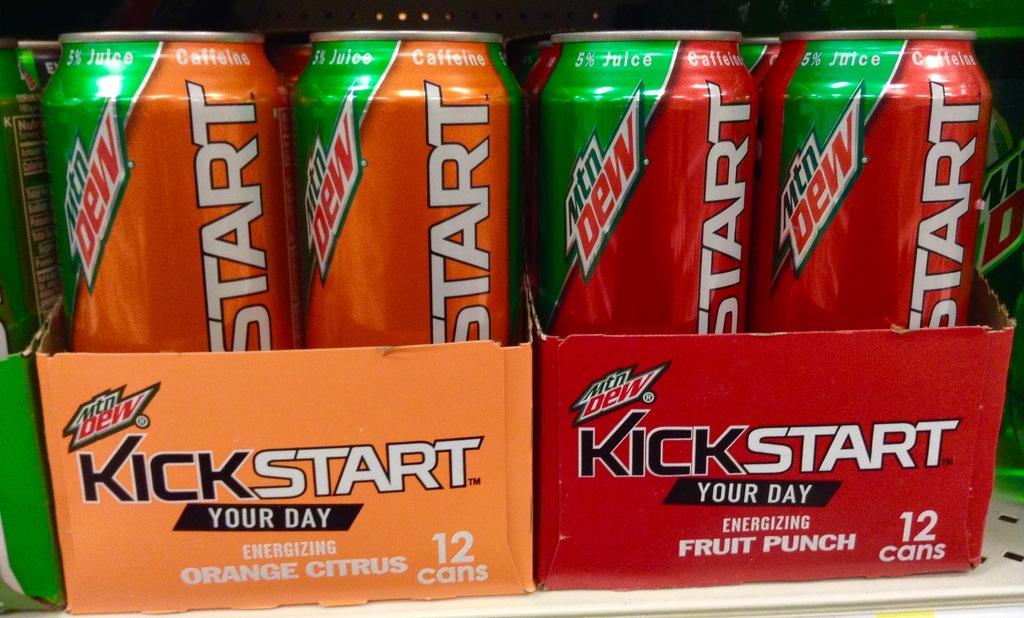What flavor is the kickstart on the right?
Keep it short and to the point. Fruit punch. How many cones contains in one packet?
Provide a short and direct response. 12. 